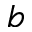Convert formula to latex. <formula><loc_0><loc_0><loc_500><loc_500>b</formula> 